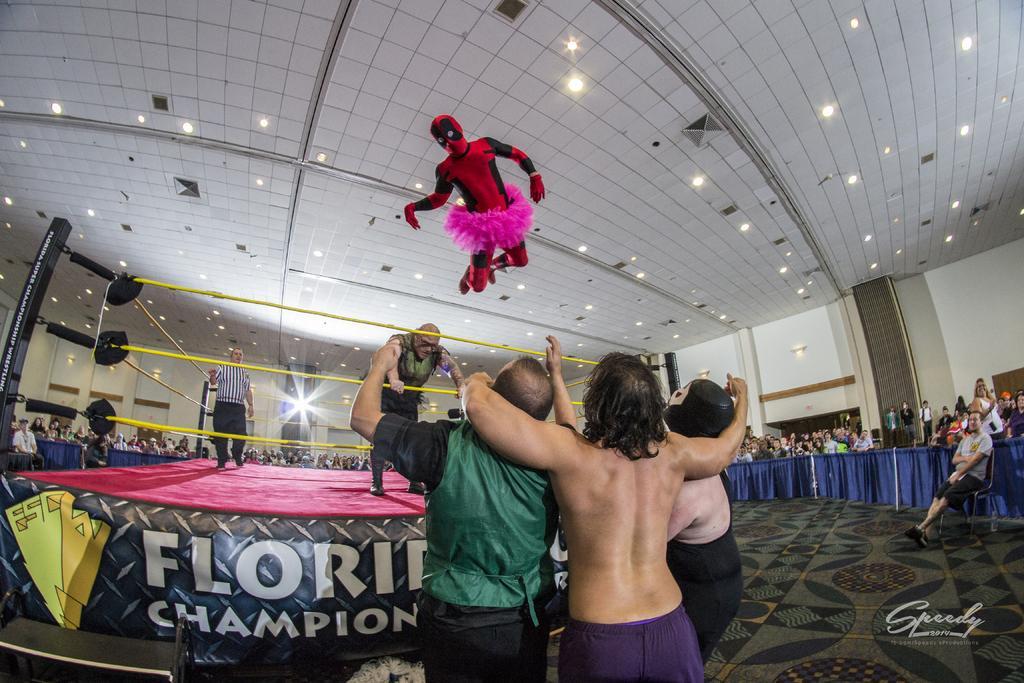Could you give a brief overview of what you see in this image? In this image there are three people standing on a floor, in front of them there is a boxing ring on that there are two people standing, at the top there is a man jumping and there is a ceiling for that ceiling there are lights, in the background there are people standing and few are sitting, on the bottom right there is some text. 